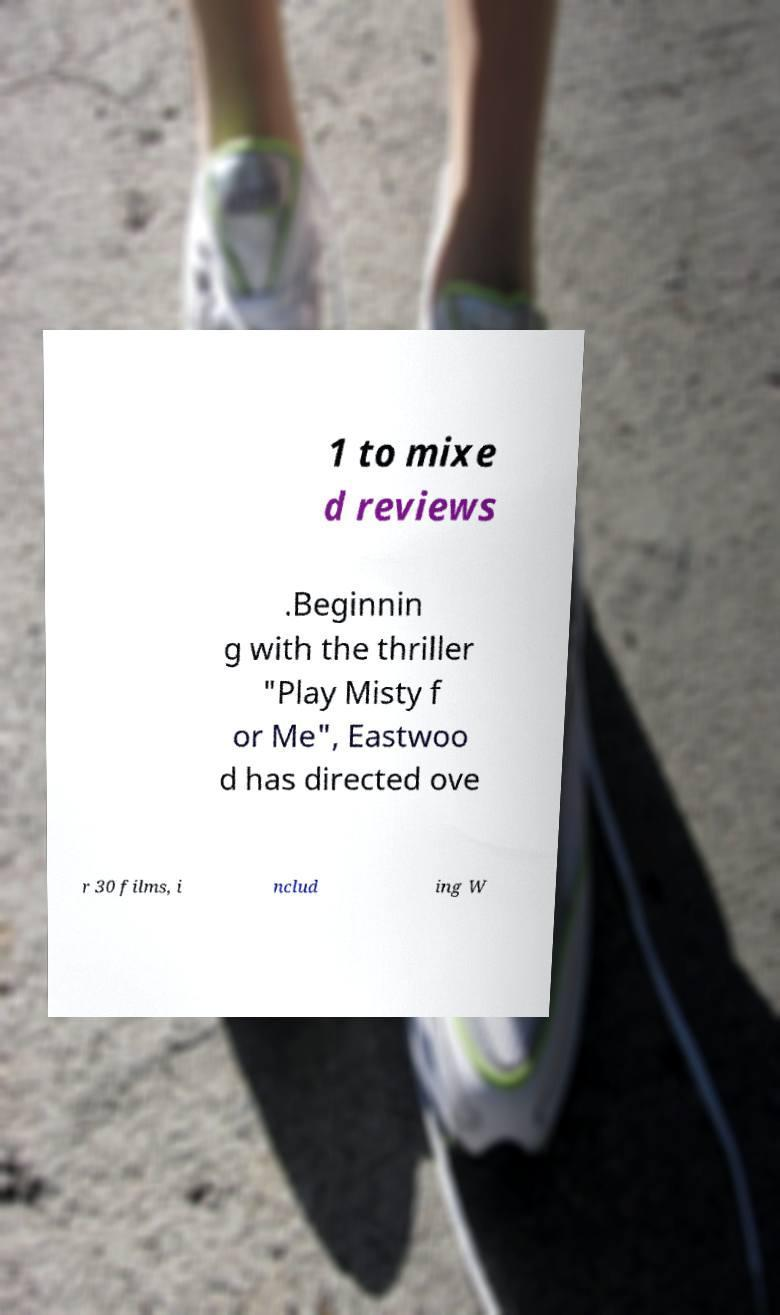Please identify and transcribe the text found in this image. 1 to mixe d reviews .Beginnin g with the thriller "Play Misty f or Me", Eastwoo d has directed ove r 30 films, i nclud ing W 